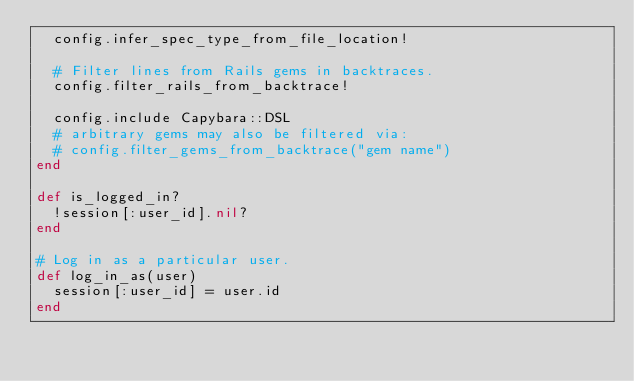<code> <loc_0><loc_0><loc_500><loc_500><_Ruby_>  config.infer_spec_type_from_file_location!

  # Filter lines from Rails gems in backtraces.
  config.filter_rails_from_backtrace!

  config.include Capybara::DSL
  # arbitrary gems may also be filtered via:
  # config.filter_gems_from_backtrace("gem name")
end

def is_logged_in?
  !session[:user_id].nil?
end

# Log in as a particular user.
def log_in_as(user)
  session[:user_id] = user.id
end
</code> 